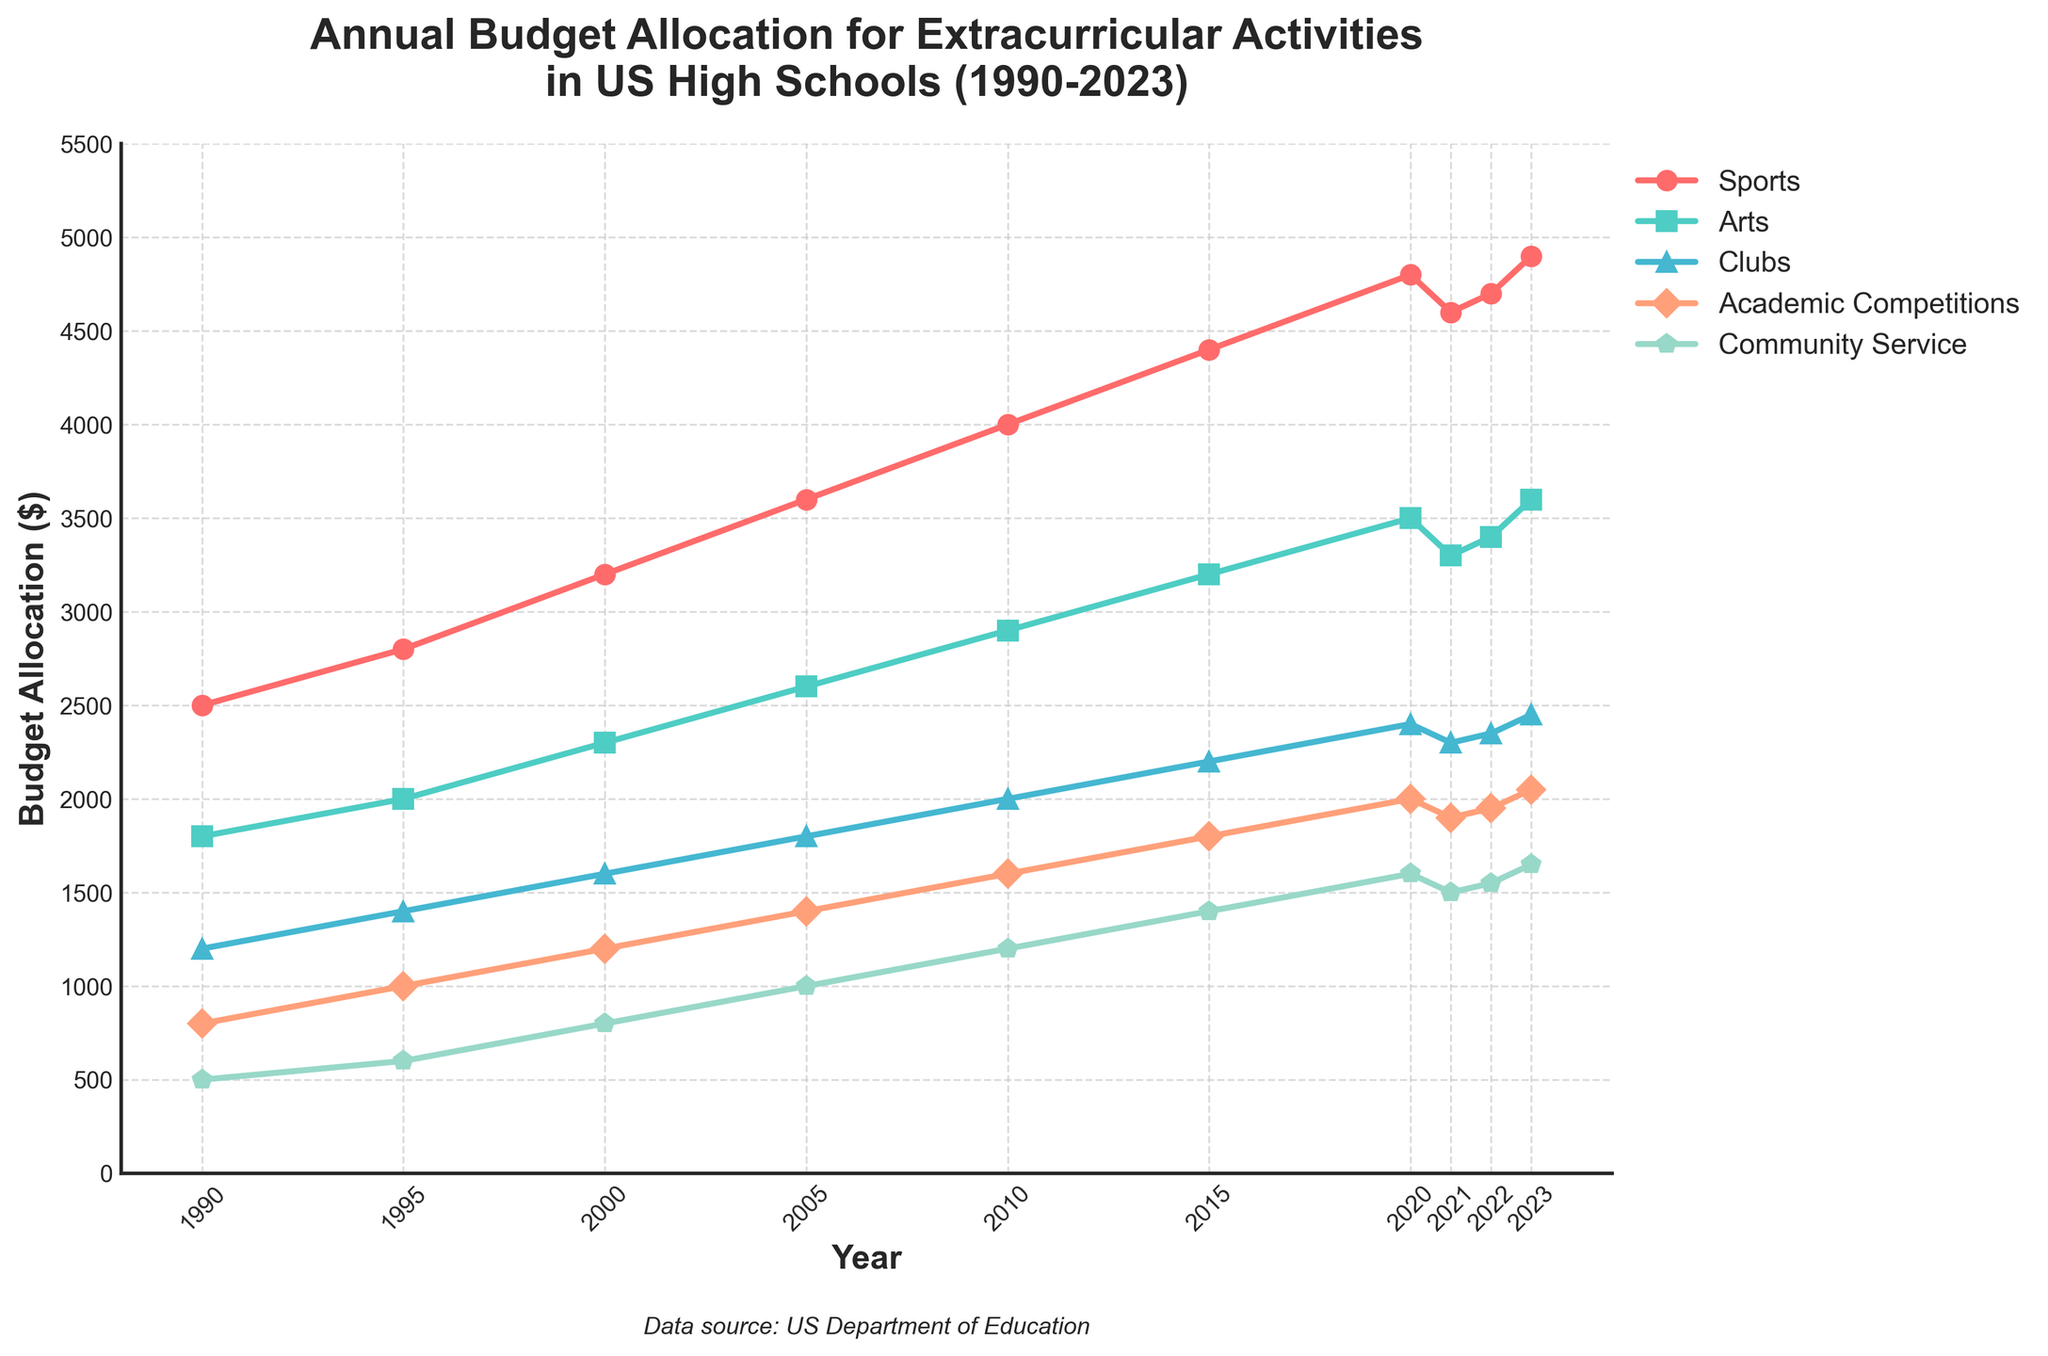What's the total budget allocation for Sports, Arts, and Clubs in 2023? Sum the amount allocated to Sports, Arts, and Clubs for the year 2023. Sports: 4900, Arts: 3600, Clubs: 2450. Total = 4900 + 3600 + 2450
Answer: 10950 Between which years did the budget allocation for Community Service see the largest single-year increase? Examine the year-on-year increase for Community Service. The largest single-year increase is seen by calculating the differences, with the highest being from 2010 (1200) to 2015 (1400) for an increase of 200.
Answer: 2010-2015 In which year did the budget allocation for Academic Competitions overtake the budget for Clubs? Compare the two lines representing Academic Competitions and Clubs over the years. Academic Competitions overtook Clubs in 2023.
Answer: 2023 What is the average budget allocation for Arts from 1990 to 2023? Add all the annual allocations for Arts and then divide by the number of years. Total = 1800 + 2000 + 2300 + 2600 + 2900 + 3200 + 3500 + 3300 + 3400 + 3600 = 28600. Number of years = 10. Average = 28600 / 10
Answer: 2860 Which activity type had the smallest budget allocation in 1990? Compare all the activities for the year 1990, the smallest is Community Service with 500.
Answer: Community Service How many times did the budget for Sports decrease between consecutive years? Examine the year-on-year budget for Sports and count the decreases: only in 2021 (4800 down to 4600).
Answer: 1 What's the difference between the highest budget allocation for Clubs and the lowest for Community Service in any given year? Highest for Clubs is 2450 (2023), lowest for Community Service is 500 (1990). Difference = 2450 - 500
Answer: 1950 Which year's budget allocation for Arts is closest to 3200? Look for the closest value to 3200 in the Arts column. The closest is 3200 itself in 2015.
Answer: 2015 In which year was the budget allocation for both Arts and Clubs equal, and what was the amount? Compare the budget values for Arts and Clubs, they are equal in 2000 with both being 2300.
Answer: 2000, 2300 